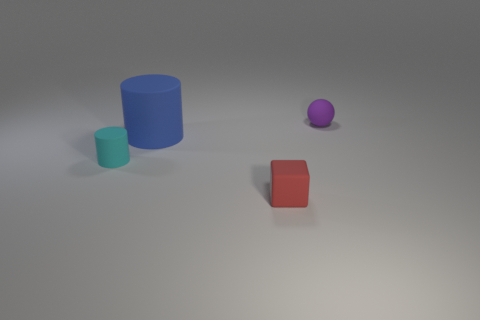There is a object to the left of the big blue cylinder; what number of tiny purple spheres are in front of it?
Offer a terse response. 0. Do the tiny red cube and the big object have the same material?
Provide a succinct answer. Yes. There is a rubber thing on the left side of the big blue rubber object that is on the left side of the tiny red object; how many matte cylinders are to the right of it?
Offer a very short reply. 1. The thing to the right of the small red object is what color?
Your response must be concise. Purple. There is a tiny object left of the cylinder behind the tiny cyan matte object; what is its shape?
Make the answer very short. Cylinder. Is the small rubber block the same color as the small cylinder?
Keep it short and to the point. No. How many cylinders are either small red matte objects or blue matte things?
Your answer should be compact. 1. What material is the thing that is right of the small cyan rubber cylinder and to the left of the red cube?
Offer a terse response. Rubber. There is a red cube; how many small matte cubes are on the right side of it?
Provide a short and direct response. 0. Is the red thing in front of the tiny cyan thing made of the same material as the small thing behind the small cyan thing?
Offer a very short reply. Yes. 